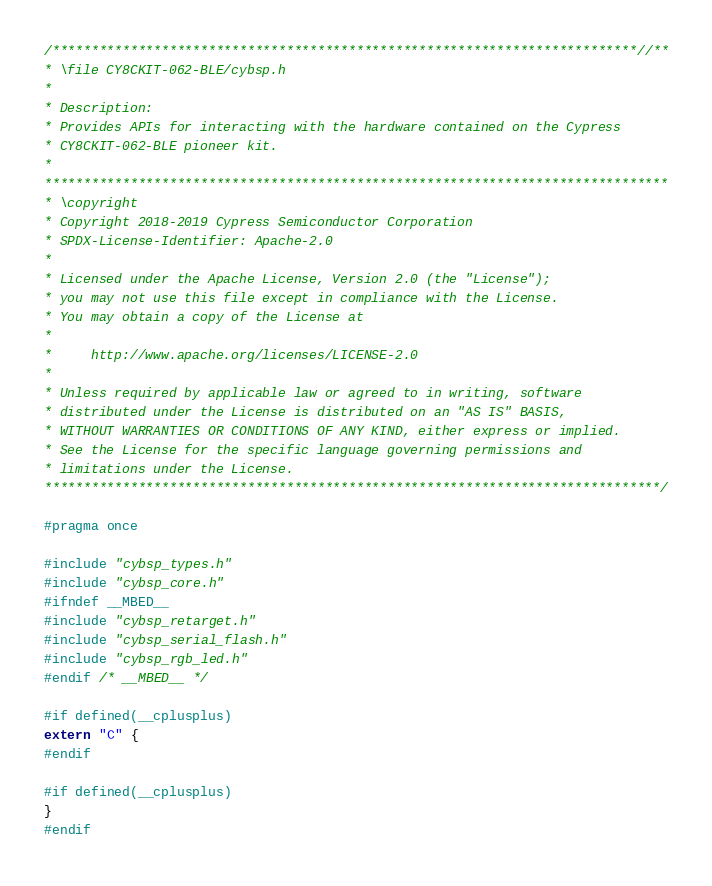Convert code to text. <code><loc_0><loc_0><loc_500><loc_500><_C_>/***************************************************************************//**
* \file CY8CKIT-062-BLE/cybsp.h
*
* Description:
* Provides APIs for interacting with the hardware contained on the Cypress
* CY8CKIT-062-BLE pioneer kit.
*
********************************************************************************
* \copyright
* Copyright 2018-2019 Cypress Semiconductor Corporation
* SPDX-License-Identifier: Apache-2.0
*
* Licensed under the Apache License, Version 2.0 (the "License");
* you may not use this file except in compliance with the License.
* You may obtain a copy of the License at
*
*     http://www.apache.org/licenses/LICENSE-2.0
*
* Unless required by applicable law or agreed to in writing, software
* distributed under the License is distributed on an "AS IS" BASIS,
* WITHOUT WARRANTIES OR CONDITIONS OF ANY KIND, either express or implied.
* See the License for the specific language governing permissions and
* limitations under the License.
*******************************************************************************/

#pragma once

#include "cybsp_types.h"
#include "cybsp_core.h"
#ifndef __MBED__
#include "cybsp_retarget.h"
#include "cybsp_serial_flash.h"
#include "cybsp_rgb_led.h"
#endif /* __MBED__ */

#if defined(__cplusplus)
extern "C" {
#endif

#if defined(__cplusplus)
}
#endif
</code> 